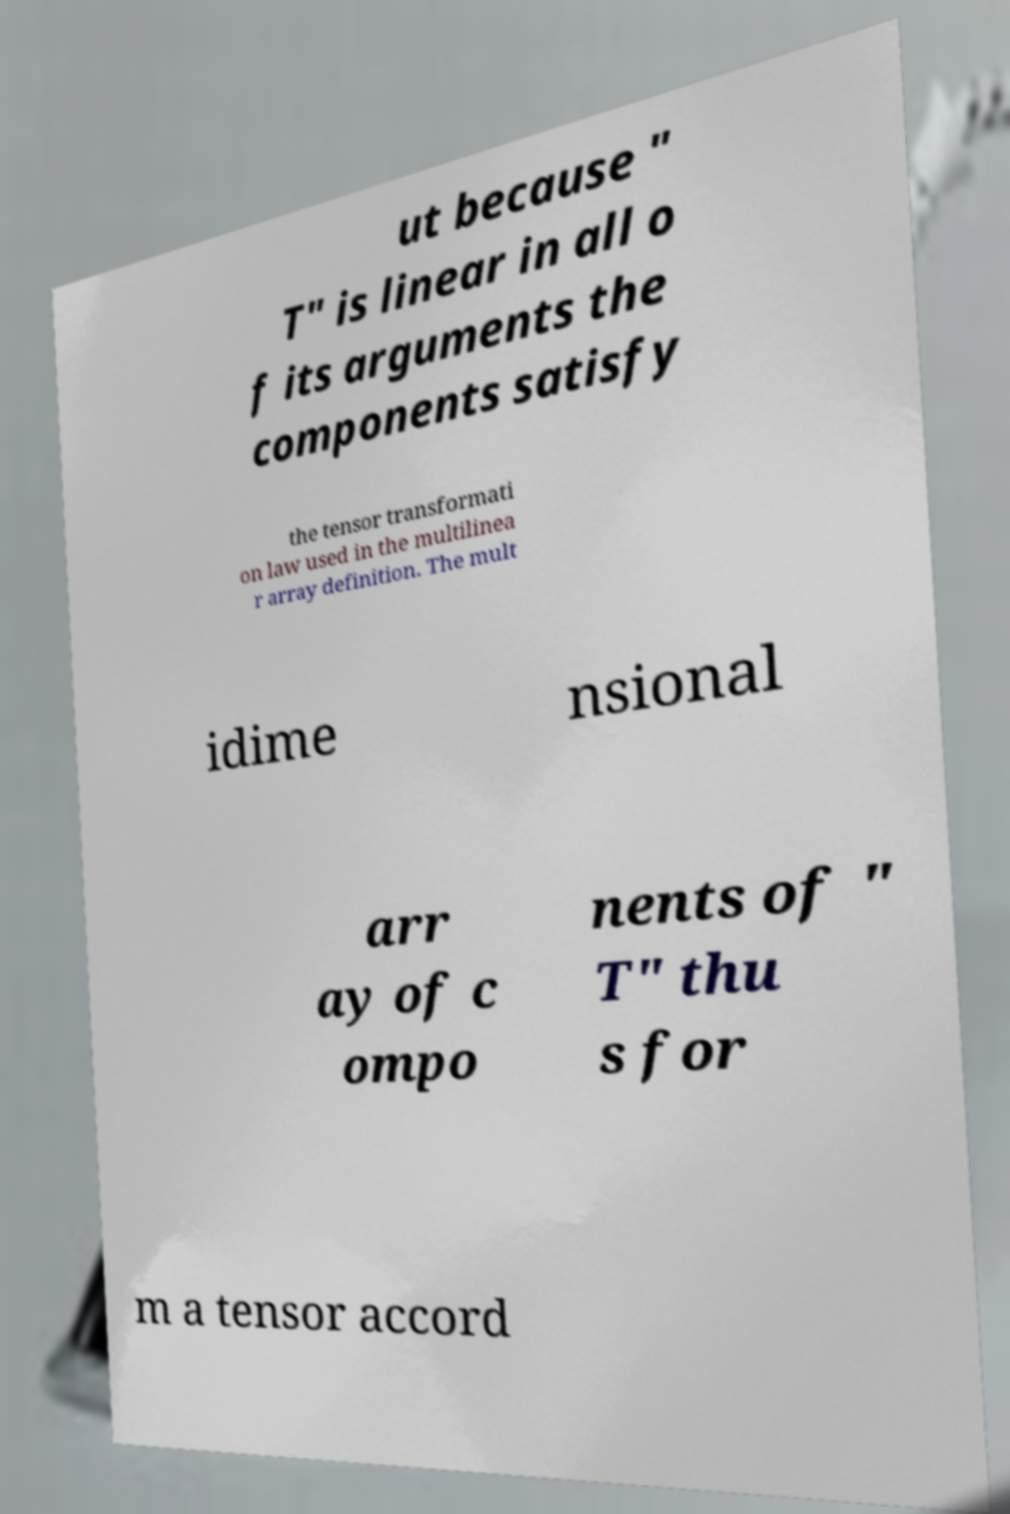Could you assist in decoding the text presented in this image and type it out clearly? ut because " T" is linear in all o f its arguments the components satisfy the tensor transformati on law used in the multilinea r array definition. The mult idime nsional arr ay of c ompo nents of " T" thu s for m a tensor accord 